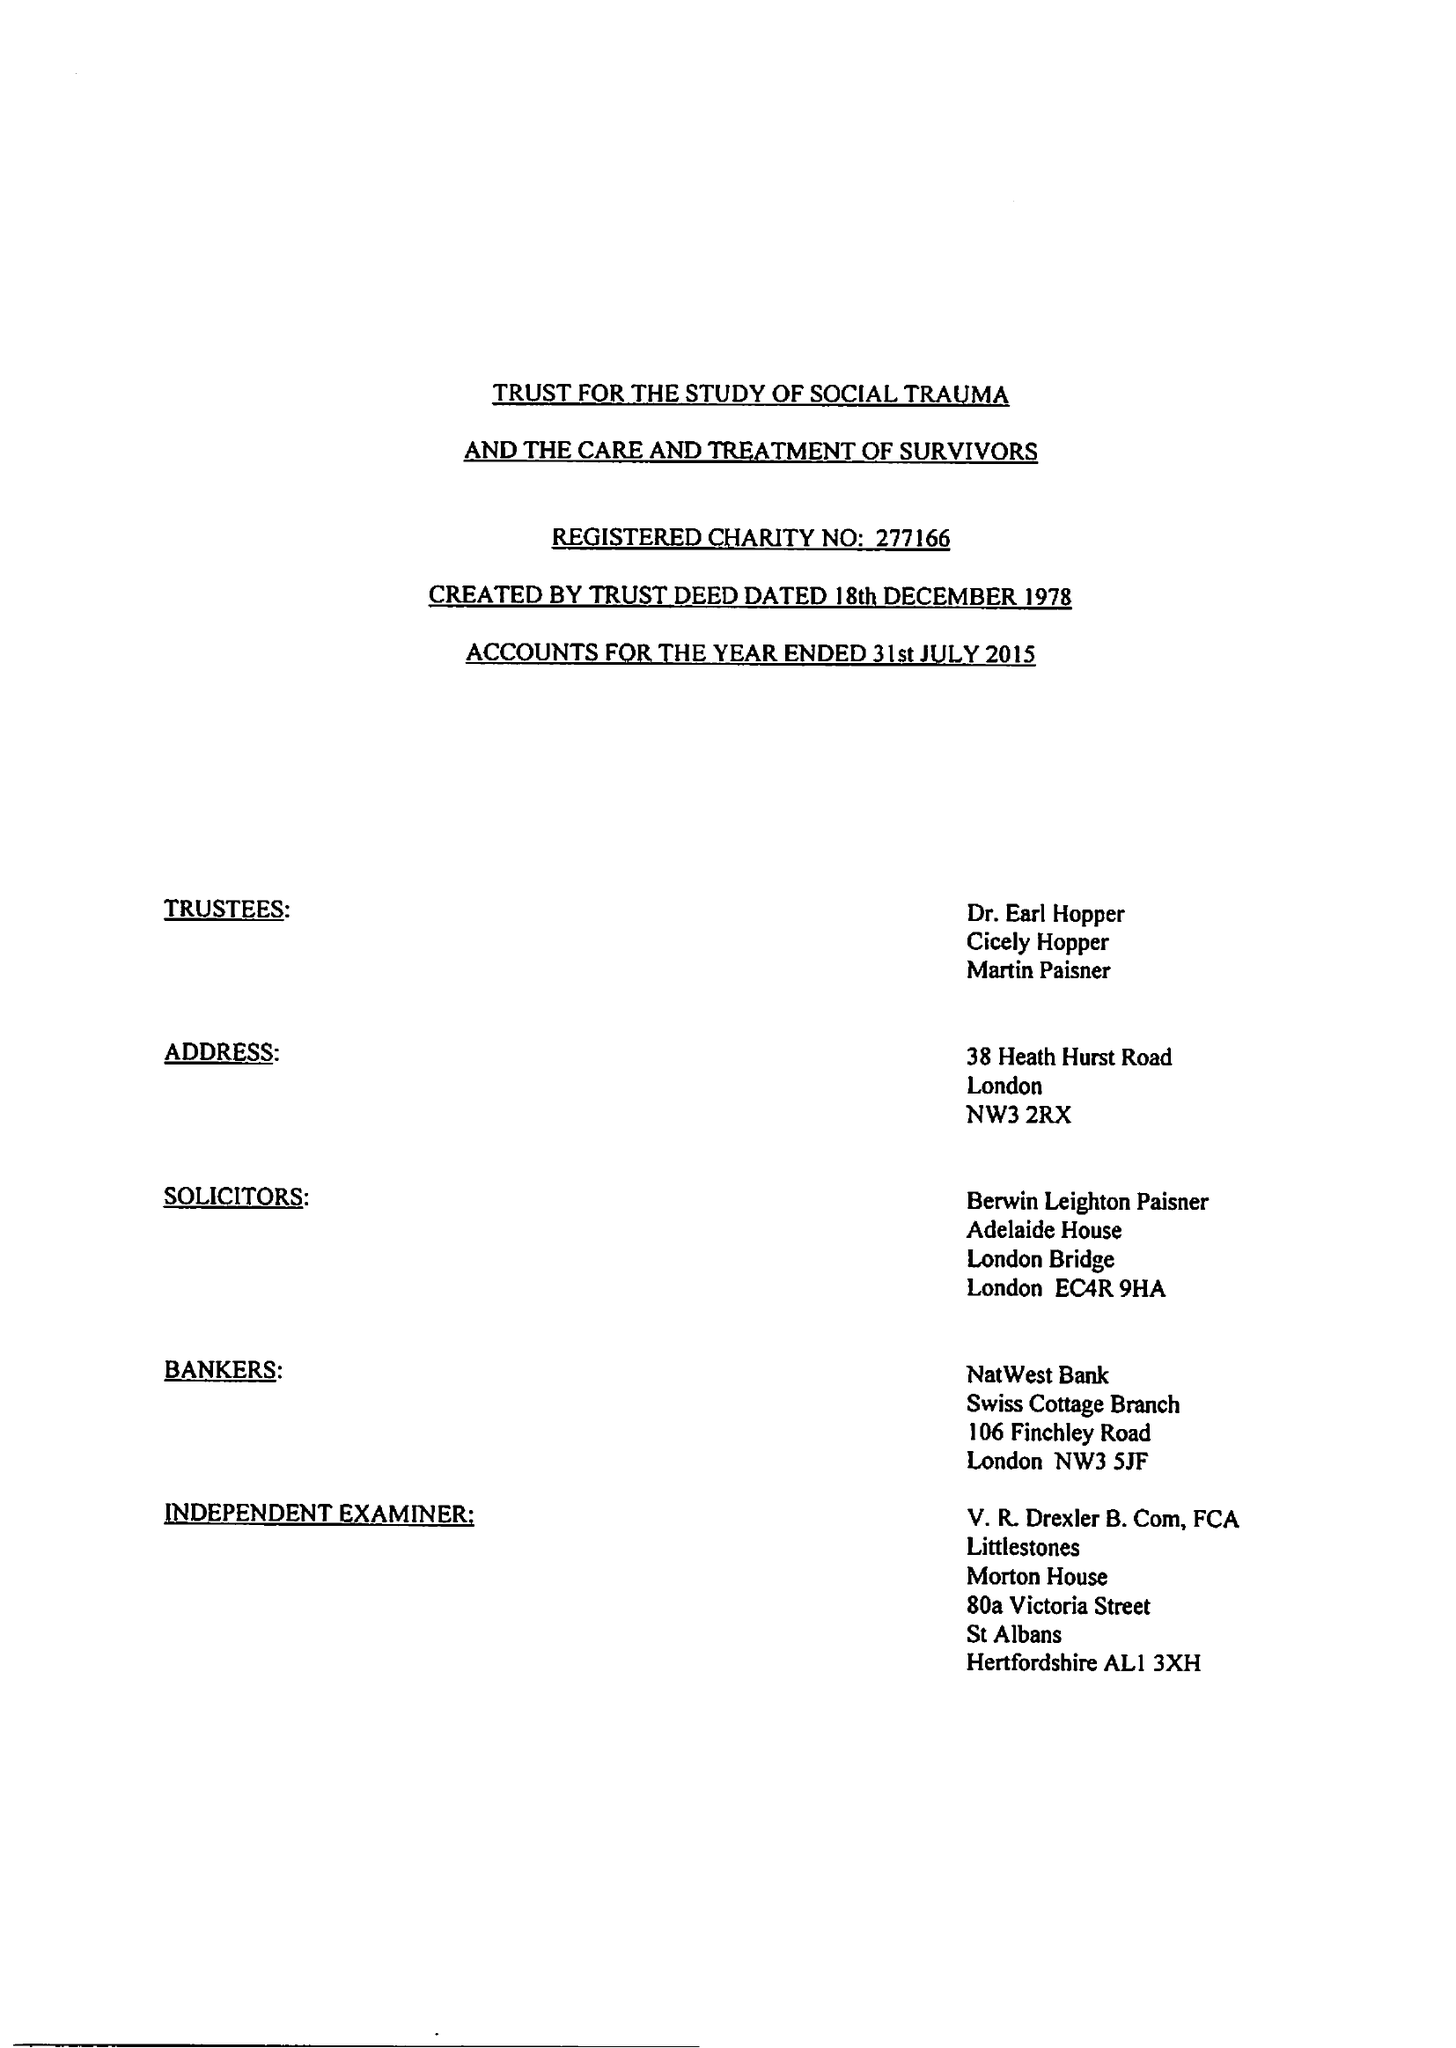What is the value for the address__post_town?
Answer the question using a single word or phrase. ST. ALBANS 